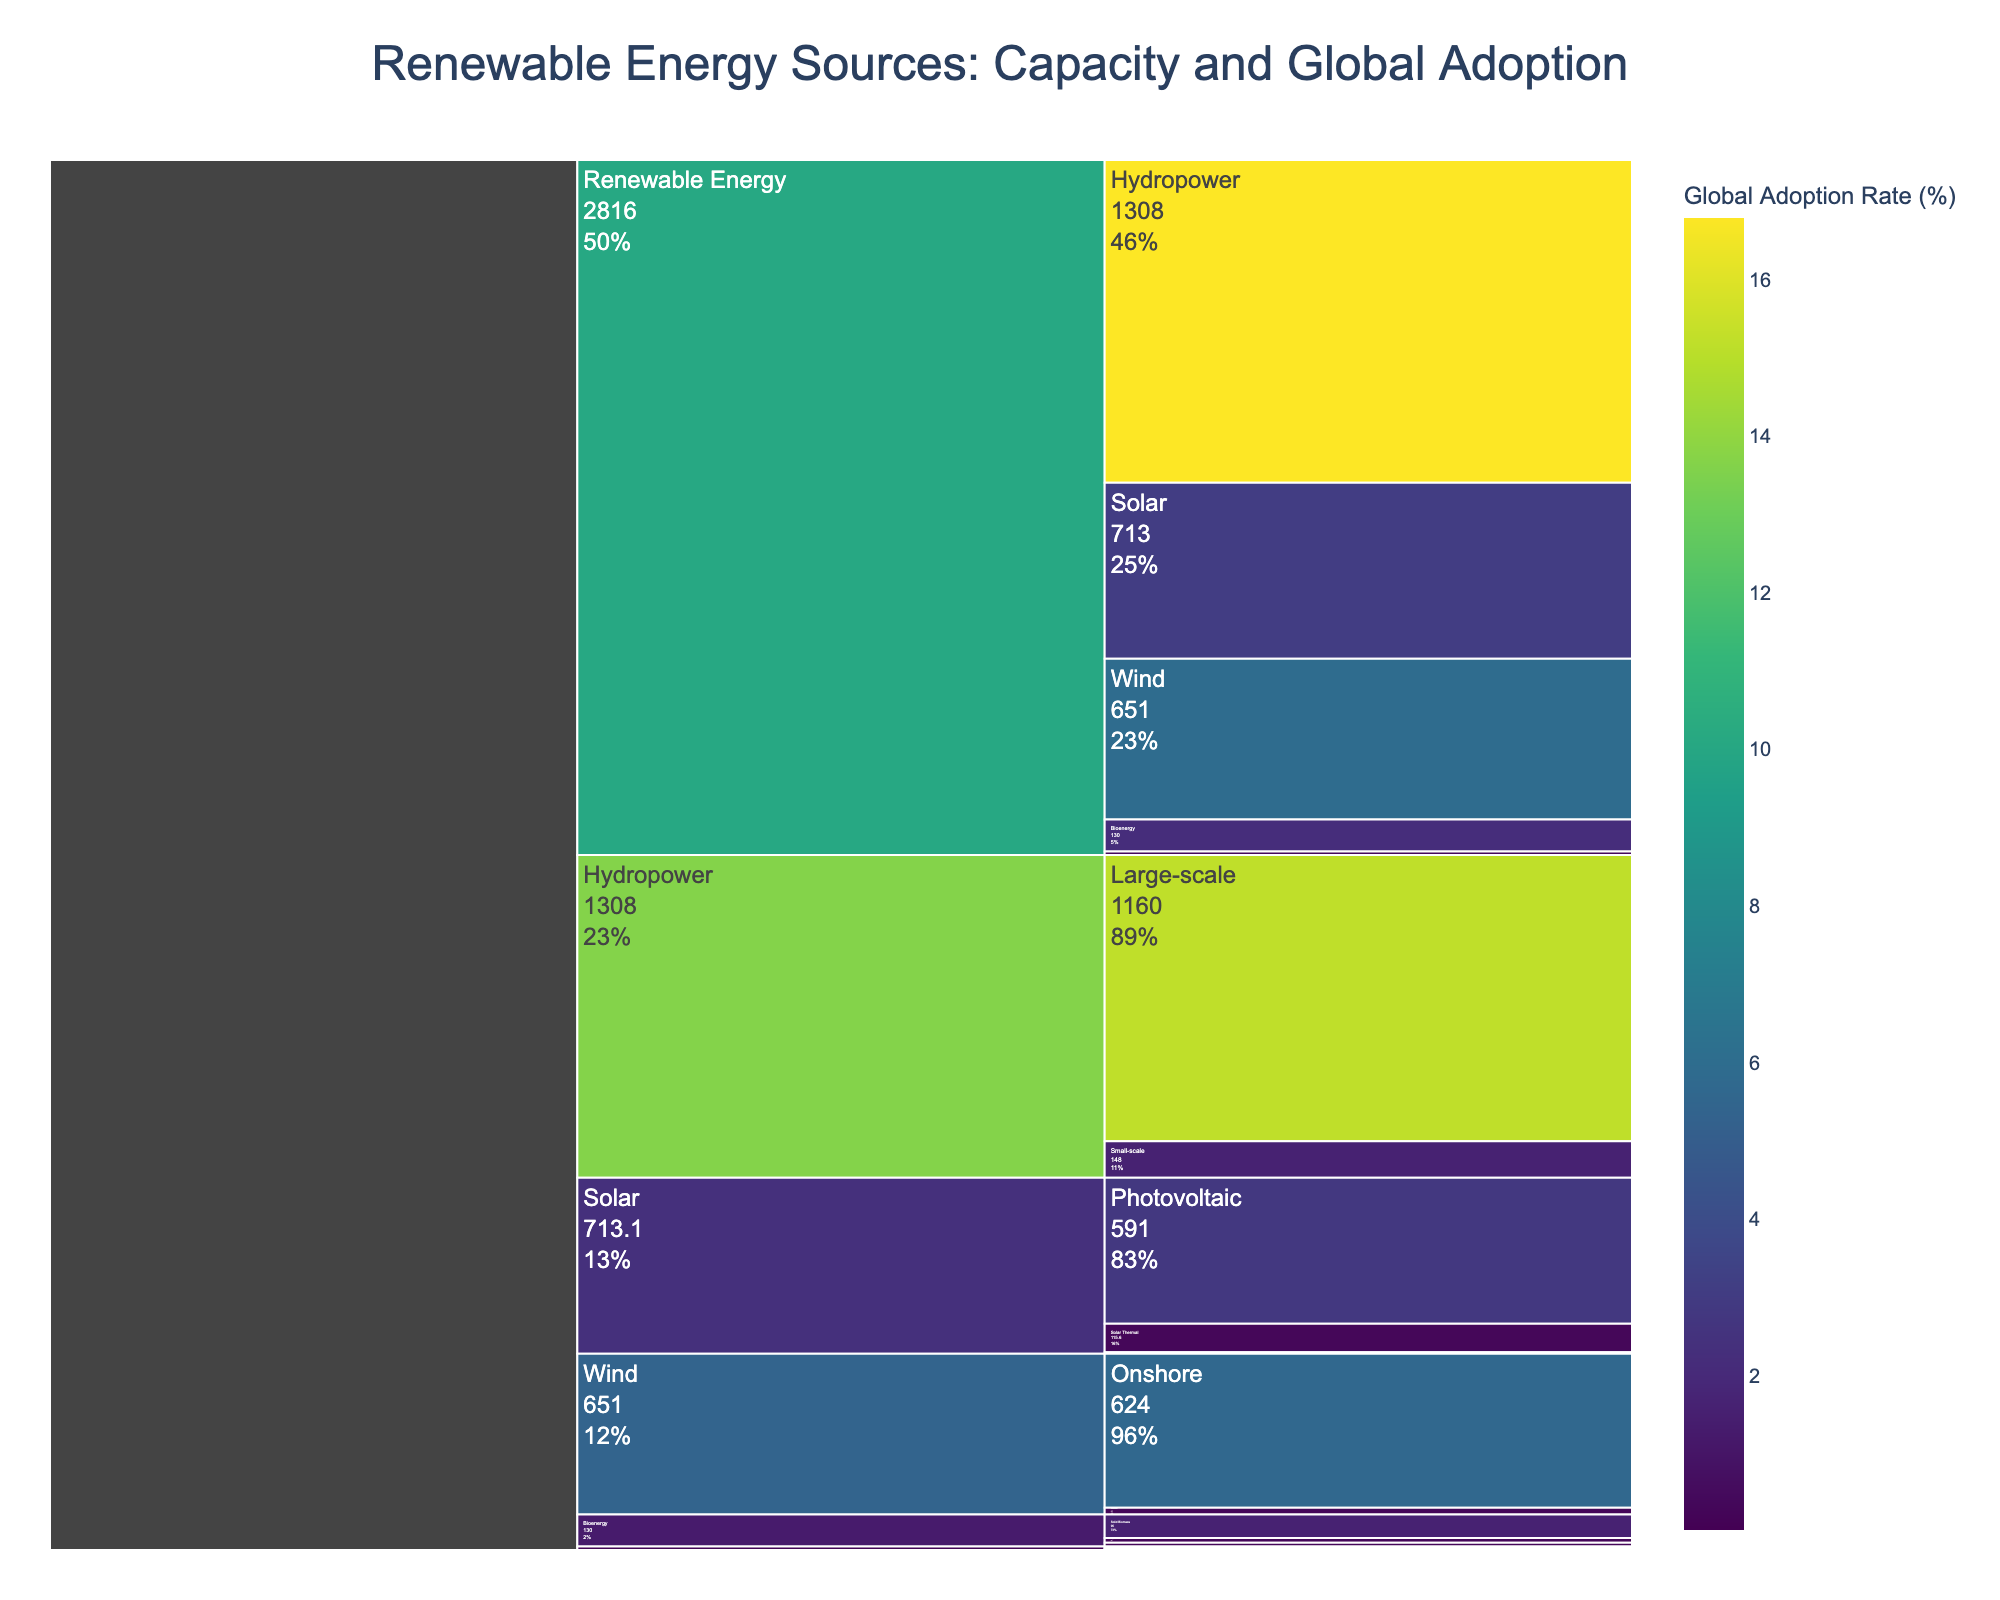What is the total capacity for wind energy? The icicle chart shows two types of wind energy: onshore (624 GW) and offshore (27 GW). Summing them up gives 624 + 27 = 651 GW.
Answer: 651 GW Which renewable energy type has the highest global adoption rate? The global adoption rates listed are: Solar (3.1%), Wind (5.9%), Hydropower (16.8%), Bioenergy (2.2%), and Geothermal (0.4%). Hydropower has the highest rate of 16.8%.
Answer: Hydropower How does the global adoption rate of photovoltaic solar compare to concentrated solar power? The adoption rate for photovoltaic solar is 2.8%, while for concentrated solar power it is 0.03%. Clearly, photovoltaic solar has a higher adoption rate compared to concentrated solar power.
Answer: Photovoltaic solar > Concentrated solar power In terms of capacity, how does large-scale hydropower compare to small-scale hydropower? Large-scale hydropower has a capacity of 1160 GW, while small-scale hydropower has a capacity of 148 GW. Large-scale hydropower has a significantly higher capacity.
Answer: Large-scale > Small-scale What is the total capacity of all solar energy subtypes combined? The capacities of solar energy subtypes are: Photovoltaic (591 GW), Concentrated Solar Power (6.5 GW), and Solar Thermal (115.6 GW). Summing these gives 591 + 6.5 + 115.6 = 713.1 GW.
Answer: 713.1 GW Which energy source has a higher adoption rate: Bioenergy or Geothermal? Bioenergy has an adoption rate of 2.2%, while Geothermal has an adoption rate of 0.4%. Therefore, Bioenergy has a higher adoption rate.
Answer: Bioenergy How do the capacities of solid biomass and liquid biofuels compare? The capacity for solid biomass is 95 GW and for liquid biofuels is 15 GW. Solid biomass has a higher capacity than liquid biofuels.
Answer: Solid biomass > Liquid biofuels What is the total global adoption rate for all types of renewable energy sources combined? Summing the global adoption rates: Solar (3.1%), Wind (5.9%), Hydropower (16.8%), Bioenergy (2.2%), Geothermal (0.4%) gives 3.1 + 5.9 + 16.8 + 2.2 + 0.4 = 28.4%.
Answer: 28.4% Which solar subtype has the lowest capacity? Comparing the capacities: Photovoltaic (591 GW), Concentrated Solar Power (6.5 GW), and Solar Thermal (115.6 GW), Concentrated Solar Power has the lowest capacity.
Answer: Concentrated Solar Power 